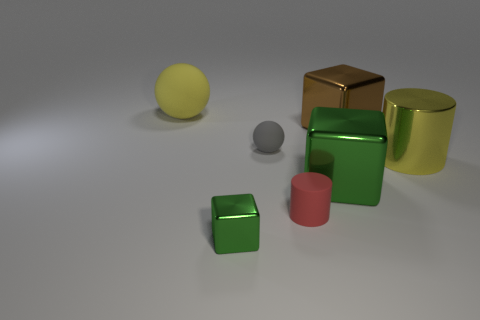Subtract all large metal blocks. How many blocks are left? 1 Add 2 big green metal objects. How many objects exist? 9 Subtract all red cylinders. How many cylinders are left? 1 Subtract 1 cubes. How many cubes are left? 2 Subtract all cubes. How many objects are left? 4 Add 1 gray matte balls. How many gray matte balls are left? 2 Add 6 tiny gray objects. How many tiny gray objects exist? 7 Subtract 2 green cubes. How many objects are left? 5 Subtract all yellow balls. Subtract all yellow cylinders. How many balls are left? 1 Subtract all brown blocks. How many red cylinders are left? 1 